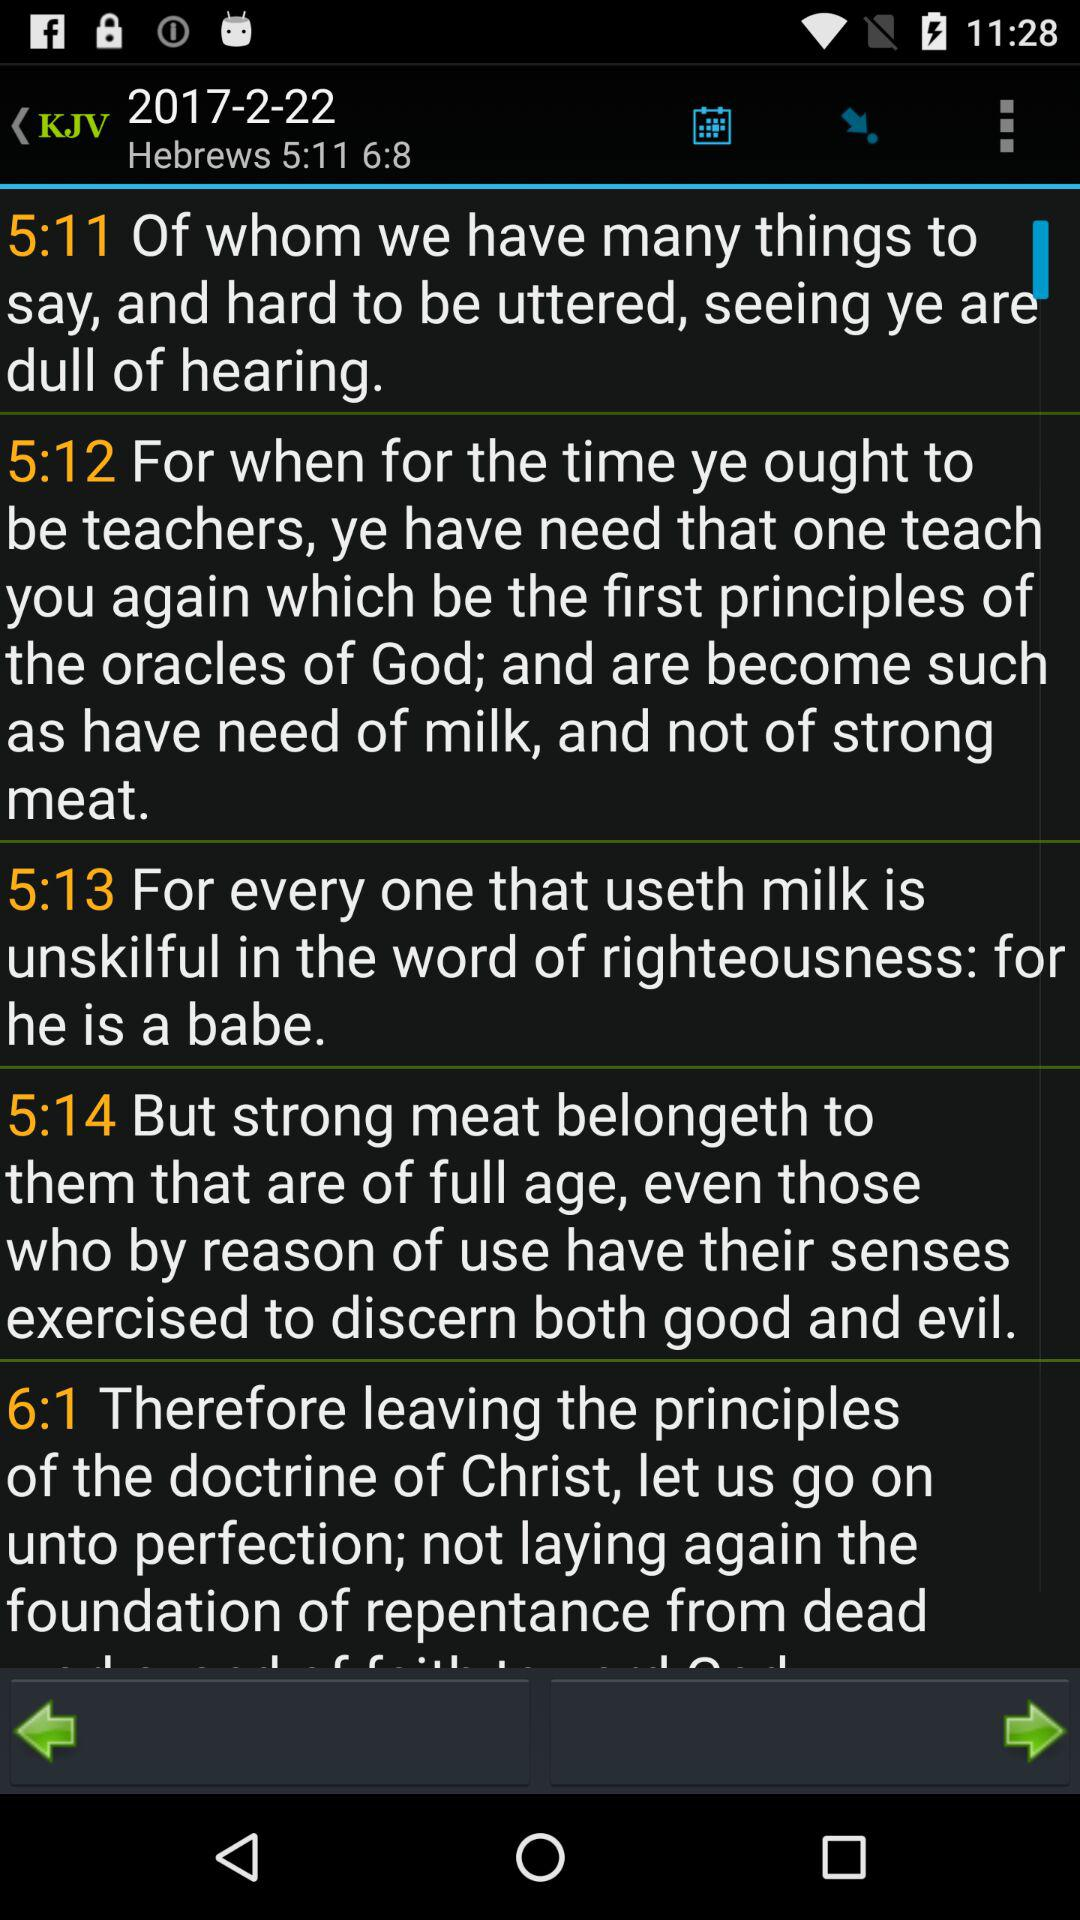Who wrote "5:11"?
When the provided information is insufficient, respond with <no answer>. <no answer> 